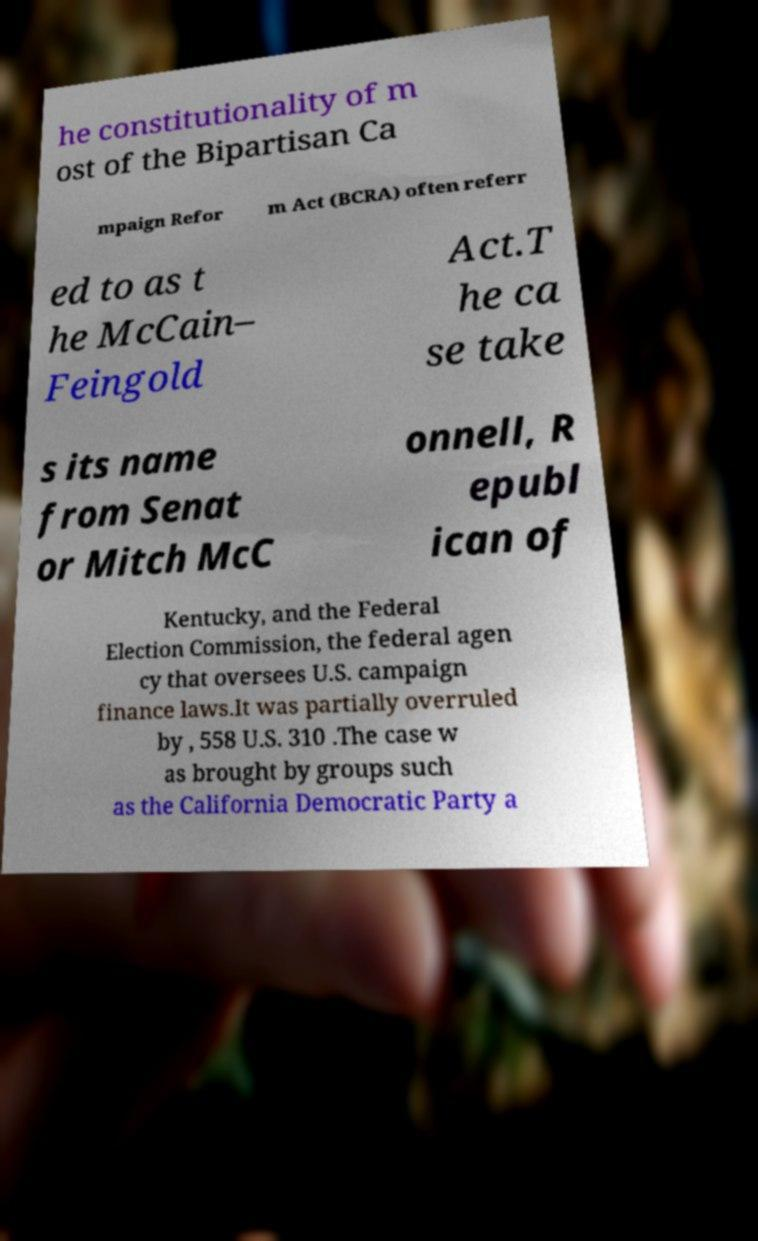What messages or text are displayed in this image? I need them in a readable, typed format. he constitutionality of m ost of the Bipartisan Ca mpaign Refor m Act (BCRA) often referr ed to as t he McCain– Feingold Act.T he ca se take s its name from Senat or Mitch McC onnell, R epubl ican of Kentucky, and the Federal Election Commission, the federal agen cy that oversees U.S. campaign finance laws.It was partially overruled by , 558 U.S. 310 .The case w as brought by groups such as the California Democratic Party a 